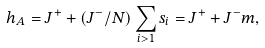<formula> <loc_0><loc_0><loc_500><loc_500>h _ { A } = J ^ { + } + ( J ^ { - } / N ) \sum _ { i > 1 } s _ { i } = J ^ { + } + J ^ { - } m ,</formula> 